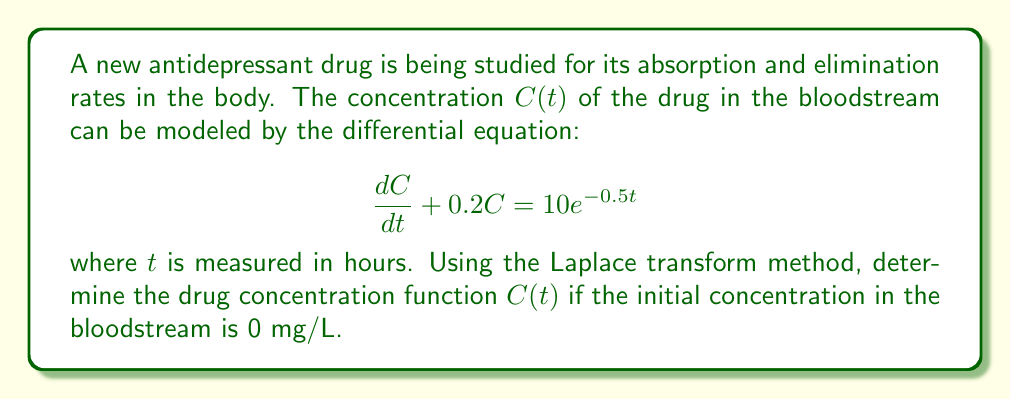Can you solve this math problem? To solve this problem using the Laplace transform method, we'll follow these steps:

1) Take the Laplace transform of both sides of the differential equation:

   $\mathcal{L}\{\frac{dC}{dt} + 0.2C\} = \mathcal{L}\{10e^{-0.5t}\}$

2) Using Laplace transform properties:

   $sC(s) - C(0) + 0.2C(s) = \frac{10}{s+0.5}$

   Where $C(s)$ is the Laplace transform of $C(t)$, and $C(0) = 0$ as given.

3) Simplify:

   $(s + 0.2)C(s) = \frac{10}{s+0.5}$

4) Solve for $C(s)$:

   $C(s) = \frac{10}{(s+0.2)(s+0.5)}$

5) Perform partial fraction decomposition:

   $C(s) = \frac{A}{s+0.2} + \frac{B}{s+0.5}$

   Where $A$ and $B$ are constants to be determined.

6) Find $A$ and $B$:

   $10 = A(s+0.5) + B(s+0.2)$
   
   When $s = -0.2$: $10 = A(0.3)$, so $A = \frac{10}{0.3} \approx 33.33$
   
   When $s = -0.5$: $10 = B(-0.3)$, so $B = -\frac{10}{0.3} \approx -33.33$

7) Rewrite $C(s)$:

   $C(s) = \frac{33.33}{s+0.2} - \frac{33.33}{s+0.5}$

8) Take the inverse Laplace transform:

   $C(t) = 33.33e^{-0.2t} - 33.33e^{-0.5t}$

This function represents the concentration of the drug in the bloodstream over time.
Answer: $C(t) = 33.33e^{-0.2t} - 33.33e^{-0.5t}$ mg/L 